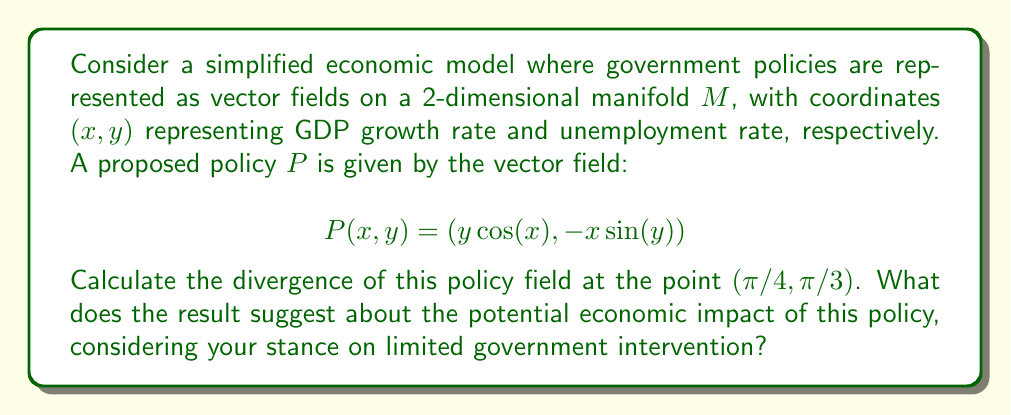Could you help me with this problem? To solve this problem, we need to follow these steps:

1) The divergence of a vector field $F(x,y) = (P(x,y), Q(x,y))$ in 2D is given by:

   $$\text{div}F = \nabla \cdot F = \frac{\partial P}{\partial x} + \frac{\partial Q}{\partial y}$$

2) In our case, $P(x,y) = y\cos(x)$ and $Q(x,y) = -x\sin(y)$. Let's calculate the partial derivatives:

   $$\frac{\partial P}{\partial x} = -y\sin(x)$$
   $$\frac{\partial Q}{\partial y} = -x\cos(y)$$

3) Now, we can write the divergence:

   $$\text{div}P = -y\sin(x) - x\cos(y)$$

4) We need to evaluate this at the point $(π/4, π/3)$:

   $$\text{div}P(π/4, π/3) = -(π/3)\sin(π/4) - (π/4)\cos(π/3)$$

5) Let's calculate this:
   
   $$\sin(π/4) = \frac{1}{\sqrt{2}}, \cos(π/3) = \frac{1}{2}$$

   $$\text{div}P(π/4, π/3) = -(π/3)\frac{1}{\sqrt{2}} - (π/4)\frac{1}{2}$$
   
   $$= -\frac{π}{3\sqrt{2}} - \frac{π}{8}$$
   
   $$= -\frac{2π\sqrt{2} + 3π}{12\sqrt{2}}$$
   
   $$\approx -0.74$$

The negative divergence suggests that this policy might lead to a contraction in the economy. From the perspective of limited government intervention, this result might be interpreted as evidence that the proposed policy could have unintended negative consequences, potentially supporting an argument for a more hands-off approach.
Answer: The divergence of the policy field at $(π/4, π/3)$ is $-\frac{2π\sqrt{2} + 3π}{12\sqrt{2}} \approx -0.74$. 